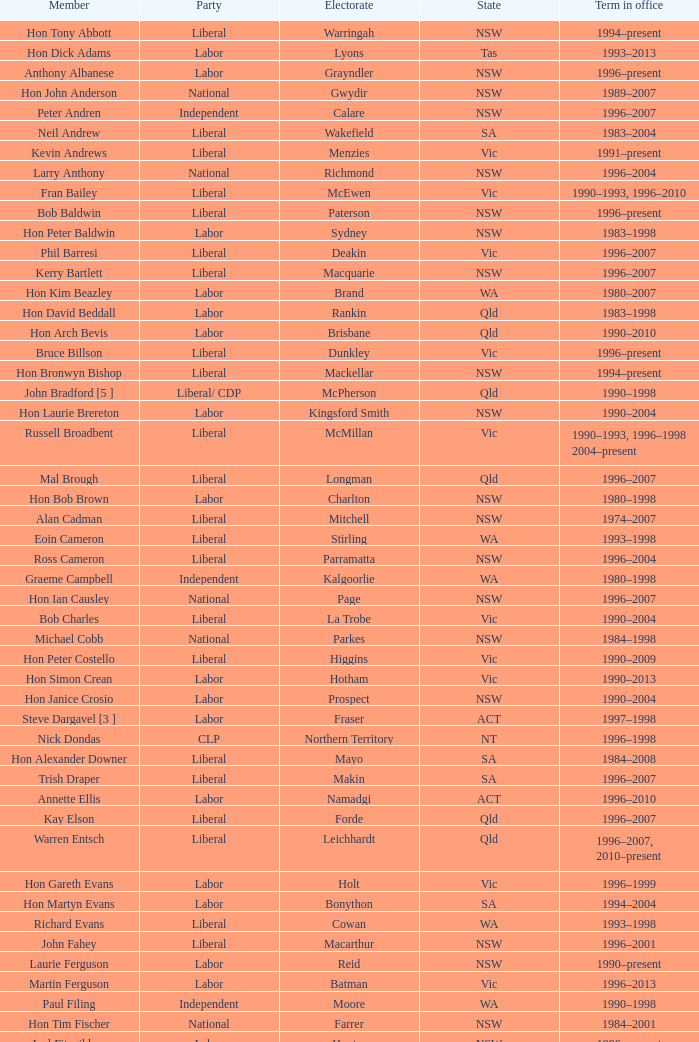In which condition was the voting population fowler? NSW. 